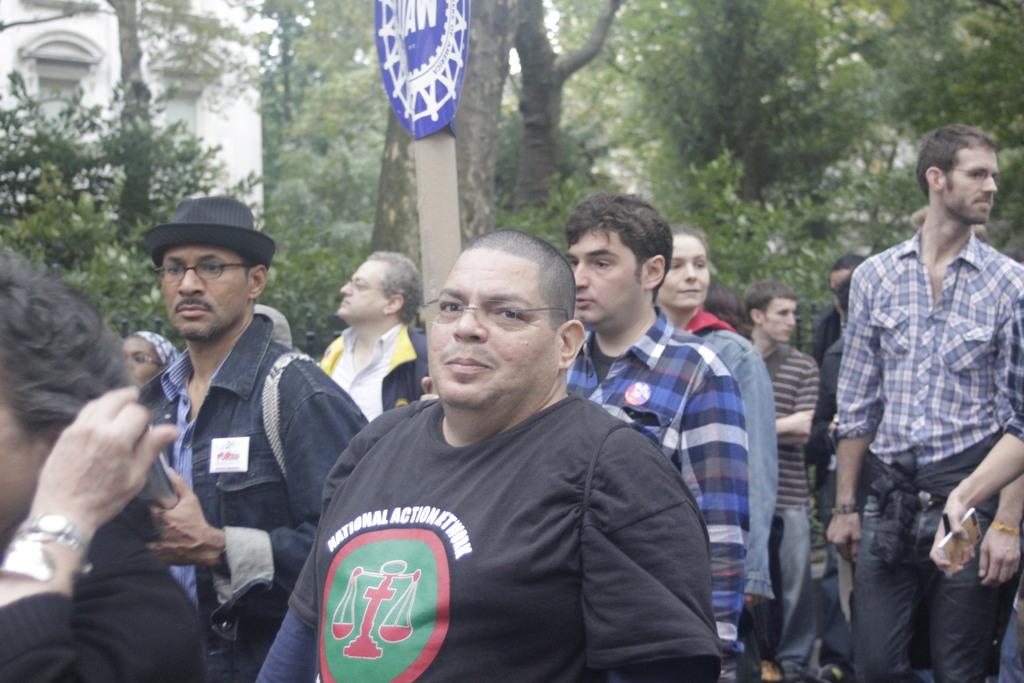What organization does the man in the black shirt represent?
Your answer should be compact. National action network. 